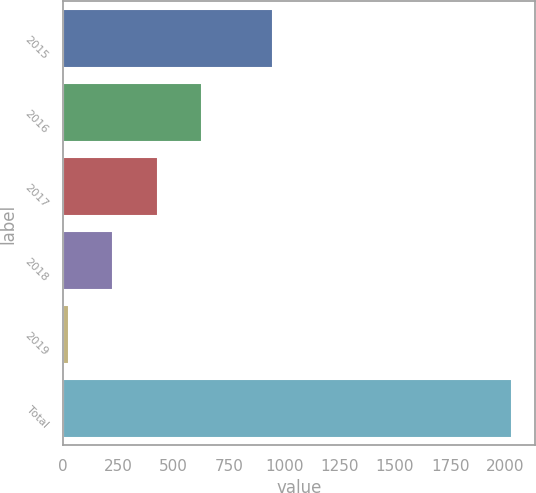Convert chart. <chart><loc_0><loc_0><loc_500><loc_500><bar_chart><fcel>2015<fcel>2016<fcel>2017<fcel>2018<fcel>2019<fcel>Total<nl><fcel>951<fcel>628.5<fcel>428<fcel>227.5<fcel>27<fcel>2032<nl></chart> 